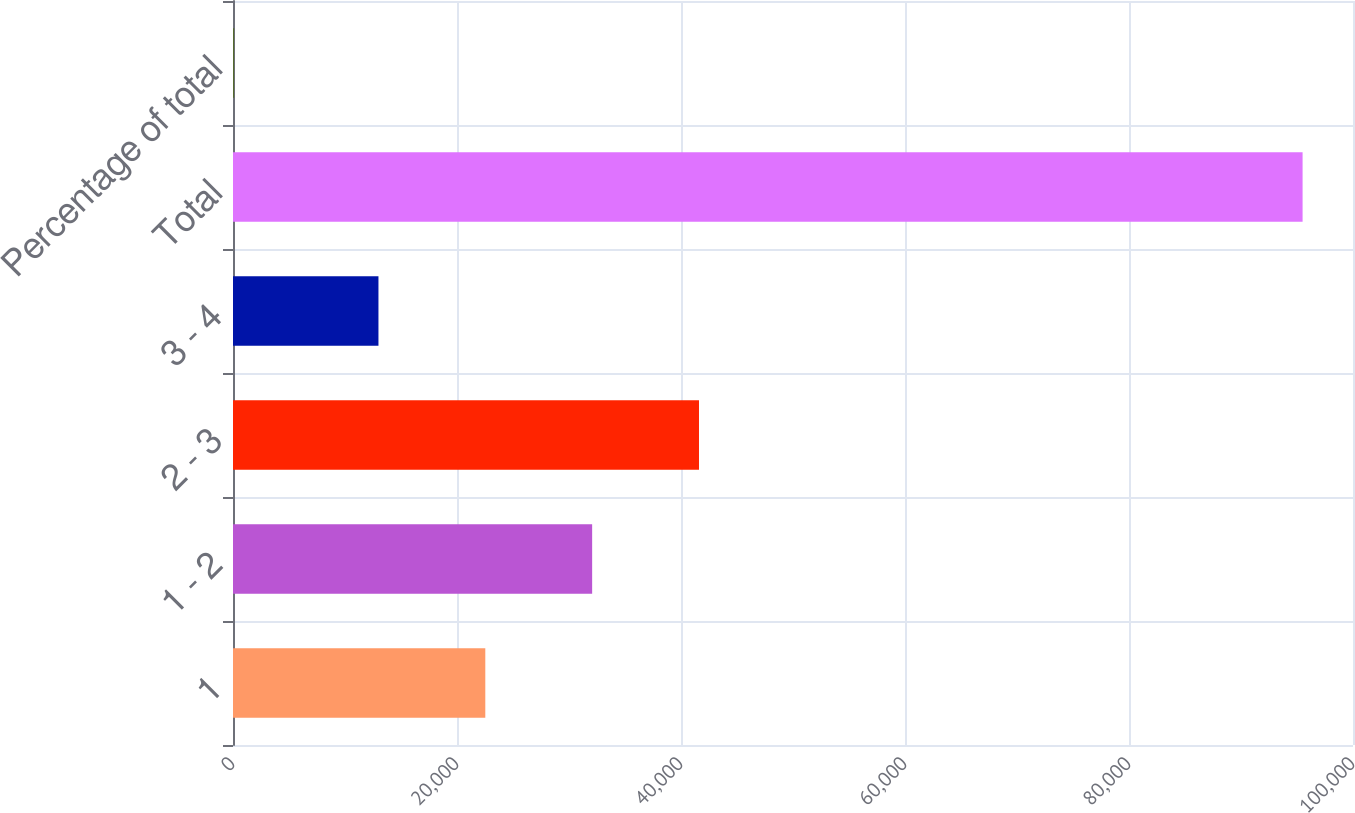Convert chart to OTSL. <chart><loc_0><loc_0><loc_500><loc_500><bar_chart><fcel>1<fcel>1 - 2<fcel>2 - 3<fcel>3 - 4<fcel>Total<fcel>Percentage of total<nl><fcel>22526.9<fcel>32066.8<fcel>41606.7<fcel>12987<fcel>95499<fcel>100<nl></chart> 